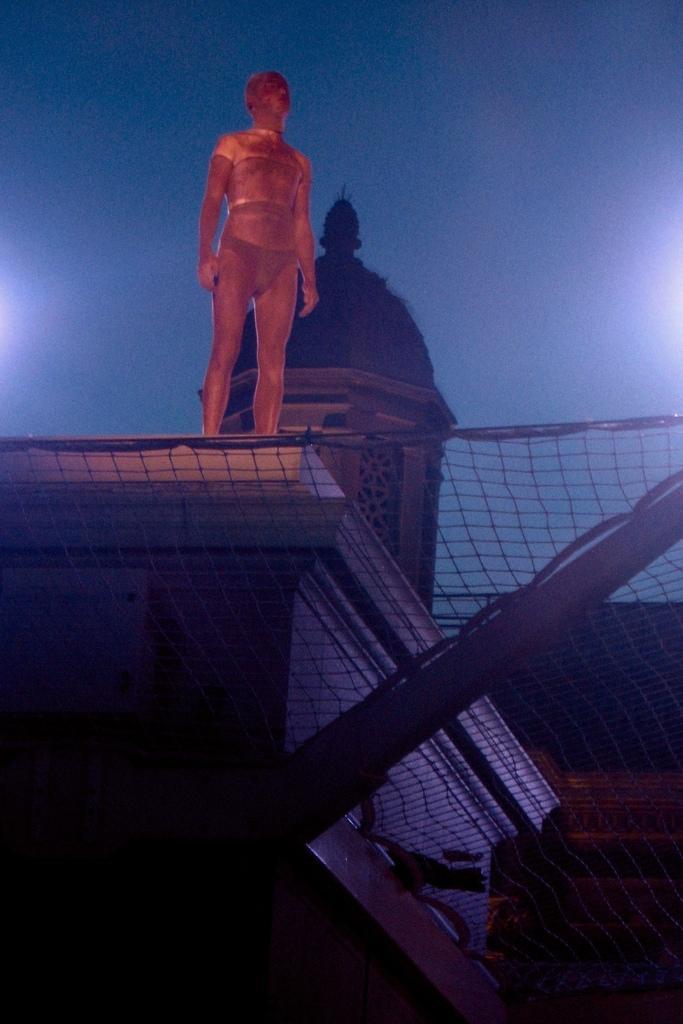Could you give a brief overview of what you see in this image? In this picture I can see the net at the bottom, in the middle there is a statue on the building. In the background it looks like the sky. 